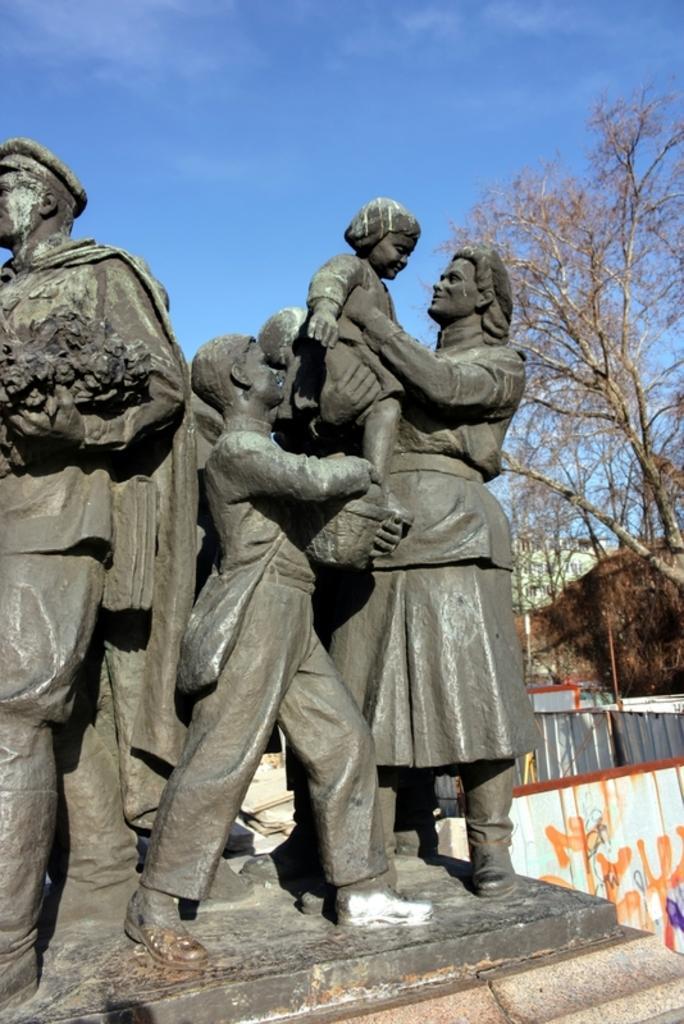Describe this image in one or two sentences. In this image I can see few statues, they are in gray color. Background I can see few dried trees and sky in blue color. 